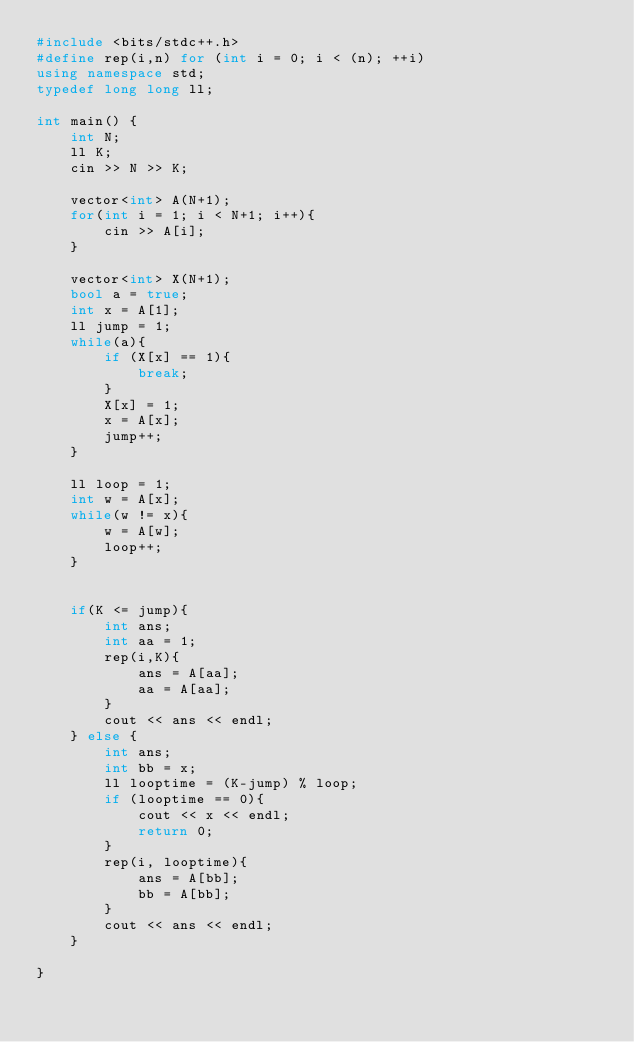Convert code to text. <code><loc_0><loc_0><loc_500><loc_500><_C++_>#include <bits/stdc++.h>
#define rep(i,n) for (int i = 0; i < (n); ++i)
using namespace std;
typedef long long ll;

int main() {
    int N;
    ll K;
    cin >> N >> K;

    vector<int> A(N+1);
    for(int i = 1; i < N+1; i++){
        cin >> A[i];
    }

    vector<int> X(N+1);
    bool a = true;
    int x = A[1];
    ll jump = 1;
    while(a){
        if (X[x] == 1){
            break;
        }
        X[x] = 1;
        x = A[x];
        jump++;
    }

    ll loop = 1;
    int w = A[x];
    while(w != x){
        w = A[w];
        loop++;
    }


    if(K <= jump){
        int ans;
        int aa = 1;
        rep(i,K){
            ans = A[aa];
            aa = A[aa];
        }
        cout << ans << endl;
    } else {
        int ans;
        int bb = x;
        ll looptime = (K-jump) % loop;
        if (looptime == 0){
            cout << x << endl;
            return 0;
        }
        rep(i, looptime){
            ans = A[bb];
            bb = A[bb];
        }
        cout << ans << endl;
    }

}</code> 